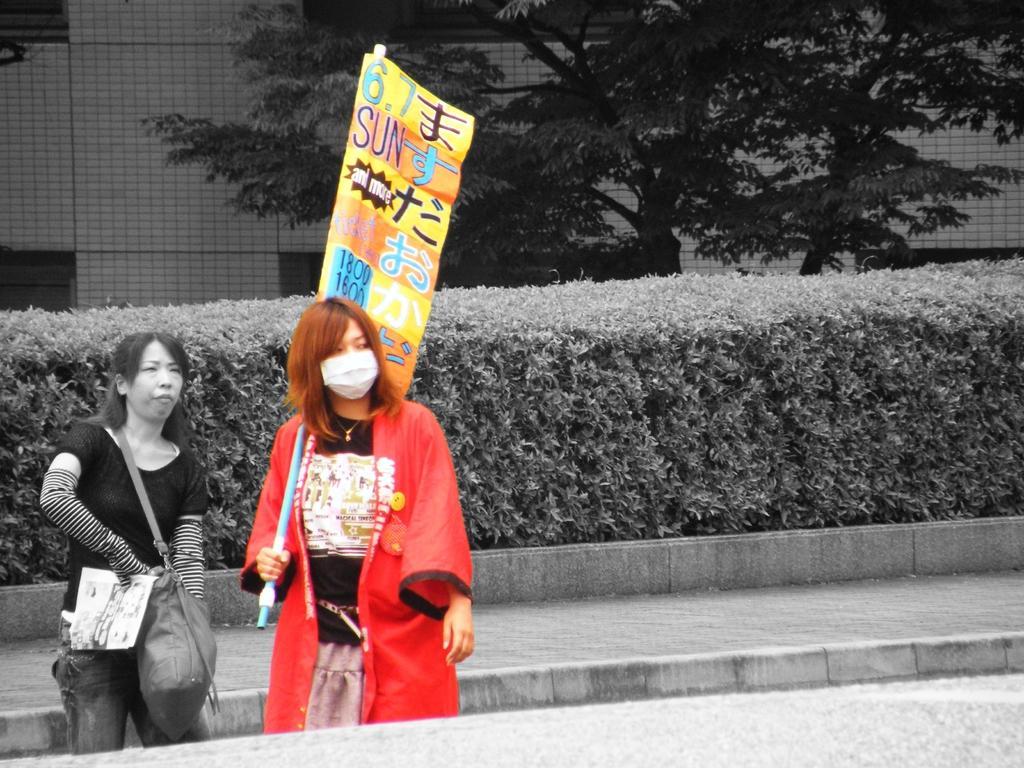Please provide a concise description of this image. In this image we can see few people and they are holding some objects in their hands. A lady is wearing the handbag in the image. There are many plants in the image. There is a tree in the image. There is a footpath in the image. There is a building in the image. 